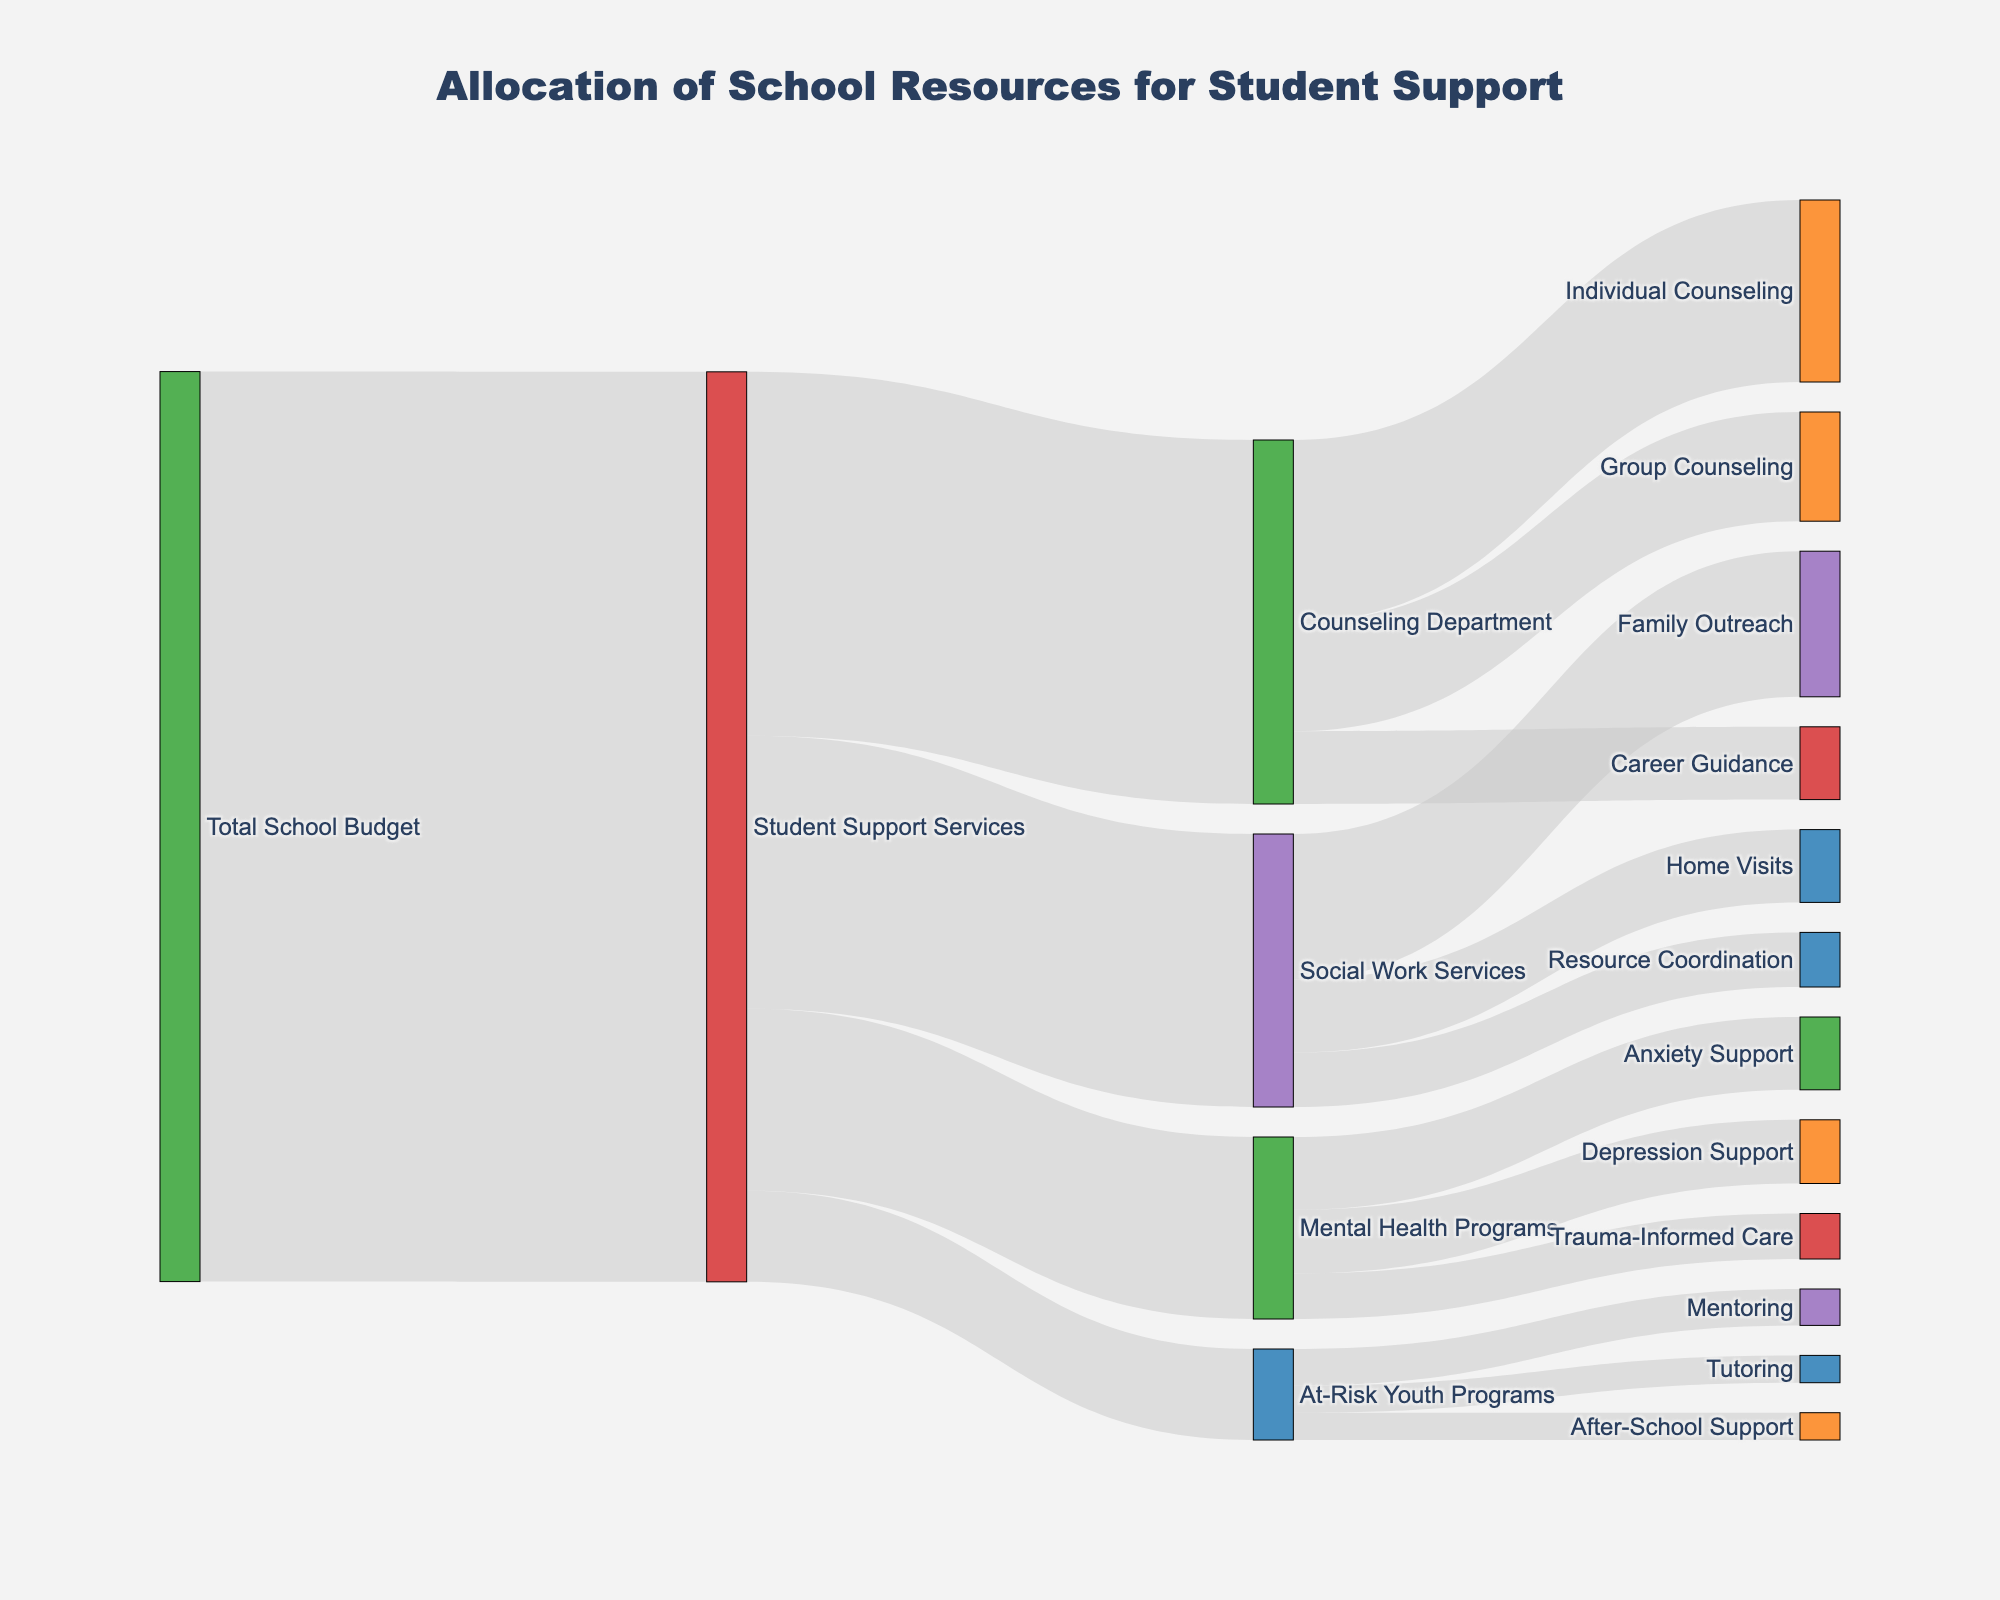What is the total budget allocated to Student Support Services? Referencing the diagram, the total budget allocation to Student Support Services originates from the Total School Budget. This is represented by the first link with a value of 500,000.
Answer: 500,000 How much of the Student Support Services budget is allocated specifically to the Counseling Department? Observing the links stemming from Student Support Services, we see that the budget allocated to the Counseling Department is 200,000.
Answer: 200,000 Which category receives the smallest allocation from At-Risk Youth Programs? The categories within At-Risk Youth Programs are Mentoring, After-School Support, and Tutoring. Among them, After-School Support and Tutoring both receive the smallest allocation of 15,000 each.
Answer: After-School Support and Tutoring How does the allocation for Individual Counseling compare to that of Career Guidance? By comparing the values for Individual Counseling and Career Guidance under the Counseling Department, Individual Counseling receives 100,000 while Career Guidance receives 40,000. Thus, Individual Counseling receives 60,000 more.
Answer: Individual Counseling receives 60,000 more What is the total budget allocated to Mental Health Programs? Summing up the allocations within Mental Health Programs: Anxiety Support (40,000), Depression Support (35,000), and Trauma-Informed Care (25,000), we get 100,000.
Answer: 100,000 How much more does Family Outreach receive compared to Resource Coordination? The Social Work Services category shows Family Outreach receiving 80,000 and Resource Coordination receiving 30,000. The difference between these is 80,000 - 30,000 = 50,000.
Answer: 50,000 Which specific programs under Student Support Services receive a budget allocation of 50,000 or less? The figure shows that At-Risk Youth Programs (50,000) distributes into Mentoring (20,000), After-School Support (15,000), and Tutoring (15,000), all of which are 50,000 or less in budget allocation.
Answer: At-Risk Youth Programs, Mentoring, After-School Support, Tutoring 